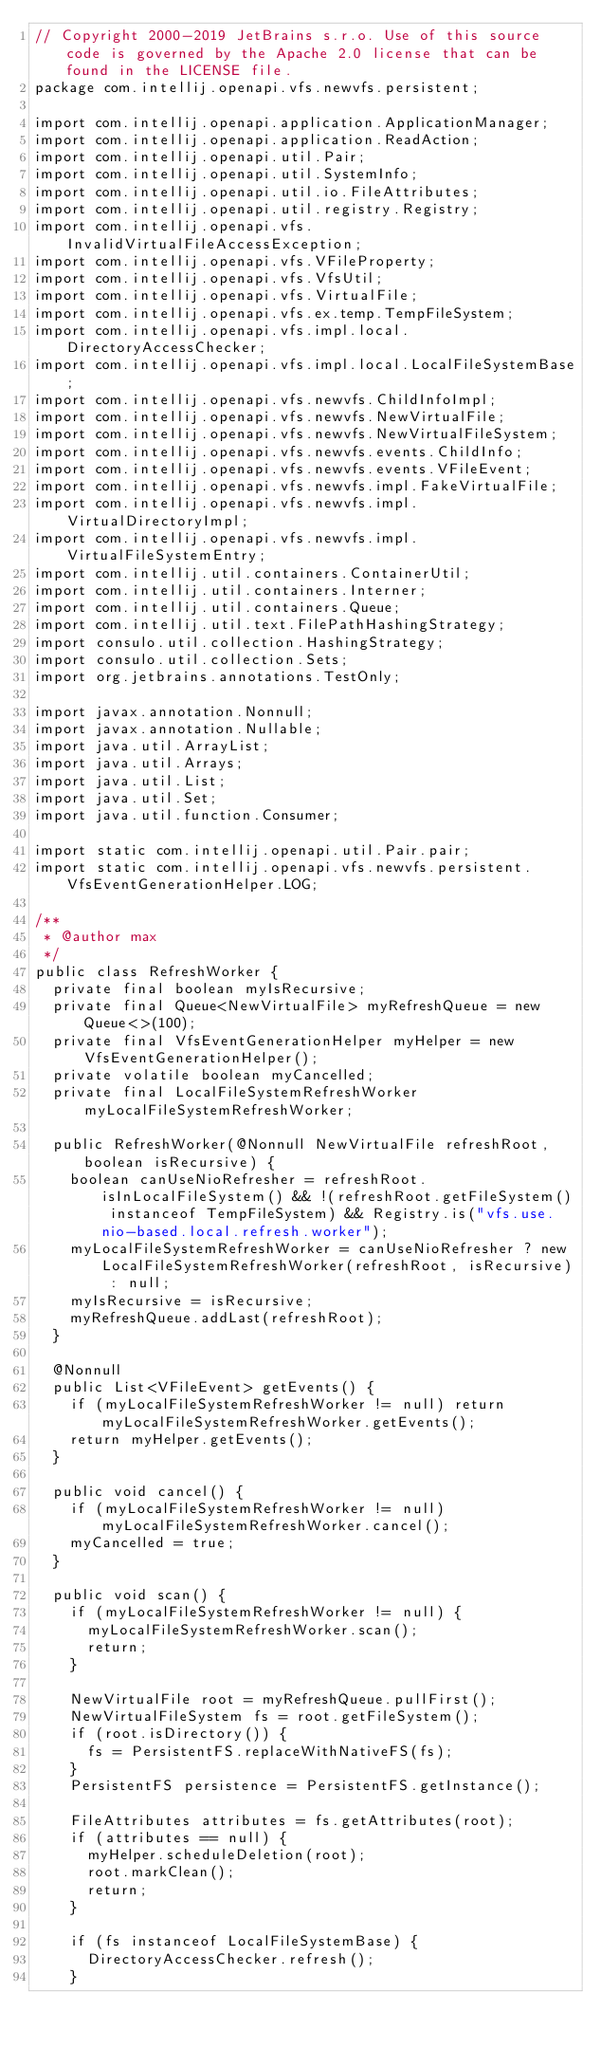Convert code to text. <code><loc_0><loc_0><loc_500><loc_500><_Java_>// Copyright 2000-2019 JetBrains s.r.o. Use of this source code is governed by the Apache 2.0 license that can be found in the LICENSE file.
package com.intellij.openapi.vfs.newvfs.persistent;

import com.intellij.openapi.application.ApplicationManager;
import com.intellij.openapi.application.ReadAction;
import com.intellij.openapi.util.Pair;
import com.intellij.openapi.util.SystemInfo;
import com.intellij.openapi.util.io.FileAttributes;
import com.intellij.openapi.util.registry.Registry;
import com.intellij.openapi.vfs.InvalidVirtualFileAccessException;
import com.intellij.openapi.vfs.VFileProperty;
import com.intellij.openapi.vfs.VfsUtil;
import com.intellij.openapi.vfs.VirtualFile;
import com.intellij.openapi.vfs.ex.temp.TempFileSystem;
import com.intellij.openapi.vfs.impl.local.DirectoryAccessChecker;
import com.intellij.openapi.vfs.impl.local.LocalFileSystemBase;
import com.intellij.openapi.vfs.newvfs.ChildInfoImpl;
import com.intellij.openapi.vfs.newvfs.NewVirtualFile;
import com.intellij.openapi.vfs.newvfs.NewVirtualFileSystem;
import com.intellij.openapi.vfs.newvfs.events.ChildInfo;
import com.intellij.openapi.vfs.newvfs.events.VFileEvent;
import com.intellij.openapi.vfs.newvfs.impl.FakeVirtualFile;
import com.intellij.openapi.vfs.newvfs.impl.VirtualDirectoryImpl;
import com.intellij.openapi.vfs.newvfs.impl.VirtualFileSystemEntry;
import com.intellij.util.containers.ContainerUtil;
import com.intellij.util.containers.Interner;
import com.intellij.util.containers.Queue;
import com.intellij.util.text.FilePathHashingStrategy;
import consulo.util.collection.HashingStrategy;
import consulo.util.collection.Sets;
import org.jetbrains.annotations.TestOnly;

import javax.annotation.Nonnull;
import javax.annotation.Nullable;
import java.util.ArrayList;
import java.util.Arrays;
import java.util.List;
import java.util.Set;
import java.util.function.Consumer;

import static com.intellij.openapi.util.Pair.pair;
import static com.intellij.openapi.vfs.newvfs.persistent.VfsEventGenerationHelper.LOG;

/**
 * @author max
 */
public class RefreshWorker {
  private final boolean myIsRecursive;
  private final Queue<NewVirtualFile> myRefreshQueue = new Queue<>(100);
  private final VfsEventGenerationHelper myHelper = new VfsEventGenerationHelper();
  private volatile boolean myCancelled;
  private final LocalFileSystemRefreshWorker myLocalFileSystemRefreshWorker;

  public RefreshWorker(@Nonnull NewVirtualFile refreshRoot, boolean isRecursive) {
    boolean canUseNioRefresher = refreshRoot.isInLocalFileSystem() && !(refreshRoot.getFileSystem() instanceof TempFileSystem) && Registry.is("vfs.use.nio-based.local.refresh.worker");
    myLocalFileSystemRefreshWorker = canUseNioRefresher ? new LocalFileSystemRefreshWorker(refreshRoot, isRecursive) : null;
    myIsRecursive = isRecursive;
    myRefreshQueue.addLast(refreshRoot);
  }

  @Nonnull
  public List<VFileEvent> getEvents() {
    if (myLocalFileSystemRefreshWorker != null) return myLocalFileSystemRefreshWorker.getEvents();
    return myHelper.getEvents();
  }

  public void cancel() {
    if (myLocalFileSystemRefreshWorker != null) myLocalFileSystemRefreshWorker.cancel();
    myCancelled = true;
  }

  public void scan() {
    if (myLocalFileSystemRefreshWorker != null) {
      myLocalFileSystemRefreshWorker.scan();
      return;
    }

    NewVirtualFile root = myRefreshQueue.pullFirst();
    NewVirtualFileSystem fs = root.getFileSystem();
    if (root.isDirectory()) {
      fs = PersistentFS.replaceWithNativeFS(fs);
    }
    PersistentFS persistence = PersistentFS.getInstance();

    FileAttributes attributes = fs.getAttributes(root);
    if (attributes == null) {
      myHelper.scheduleDeletion(root);
      root.markClean();
      return;
    }

    if (fs instanceof LocalFileSystemBase) {
      DirectoryAccessChecker.refresh();
    }
</code> 